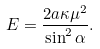Convert formula to latex. <formula><loc_0><loc_0><loc_500><loc_500>E = \frac { 2 a \kappa \mu ^ { 2 } } { \sin ^ { 2 } \alpha } .</formula> 